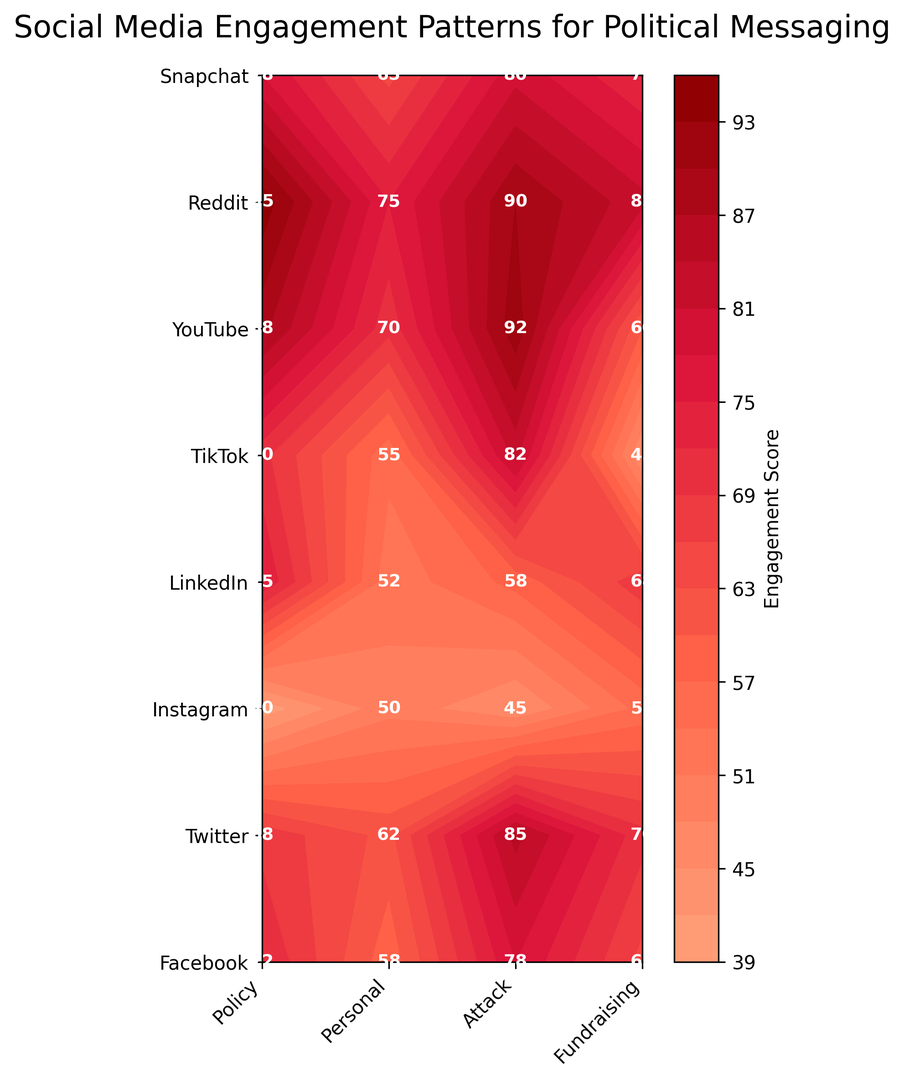Which platform has the highest engagement score for Policy messages? By looking at the contours and the specific labels on the figure, check for the highest score among all Policy messages for each platform. The highest value is 82 on Twitter.
Answer: Twitter Which platform has the lowest engagement score for Attack messages? Examine the contour labels for Attack messages across all platforms. The lowest engagement score is on LinkedIn, with a score of 40.
Answer: LinkedIn What is the difference between the engagement scores of Personal messages on TikTok and LinkedIn? The engagement score for Personal messages on TikTok is 92 and on LinkedIn is 45. The difference is 92 - 45 = 47.
Answer: 47 For which message type does Twitter have the highest engagement score? Check the engagement scores for each message type on Twitter. The highest score is 95 for Attack messages.
Answer: Attack Which message type has the most consistent engagement score across platforms? Compare the variation in engagement scores for each message type across different platforms visually. Policy messages have relatively consistent scores with smaller gaps between the highest and lowest scores compared to other message types.
Answer: Policy What is the average engagement score of Fundraising messages across all platforms? Sum all the engagement scores for Fundraising messages (58, 75, 62, 50, 70, 65, 52, 55) and divide by the number of platforms (8). The calculation is (58 + 75 + 62 + 50 + 70 + 65 + 52 + 55) / 8 = 61.
Answer: 61 Which platform has the most diverse engagement scores across all message types? Identify the platform with the largest range of engagement scores across all message types. LinkedIn has the widest range from 40 to 55, indicating diverse engagement scores.
Answer: LinkedIn How do the engagement scores for Personal messages on YouTube and Twitter compare? Check the engagement scores on the contour for YouTube and Twitter for Personal messages. YouTube has a score of 80, and Twitter has 90. YouTube < Twitter for Personal messages.
Answer: Twitter What color represents the highest engagement scores on the contour plot? Identify the color gradient used for the highest engagement scores on the plot. The darkest red color corresponds to the highest engagement scores.
Answer: Dark red 